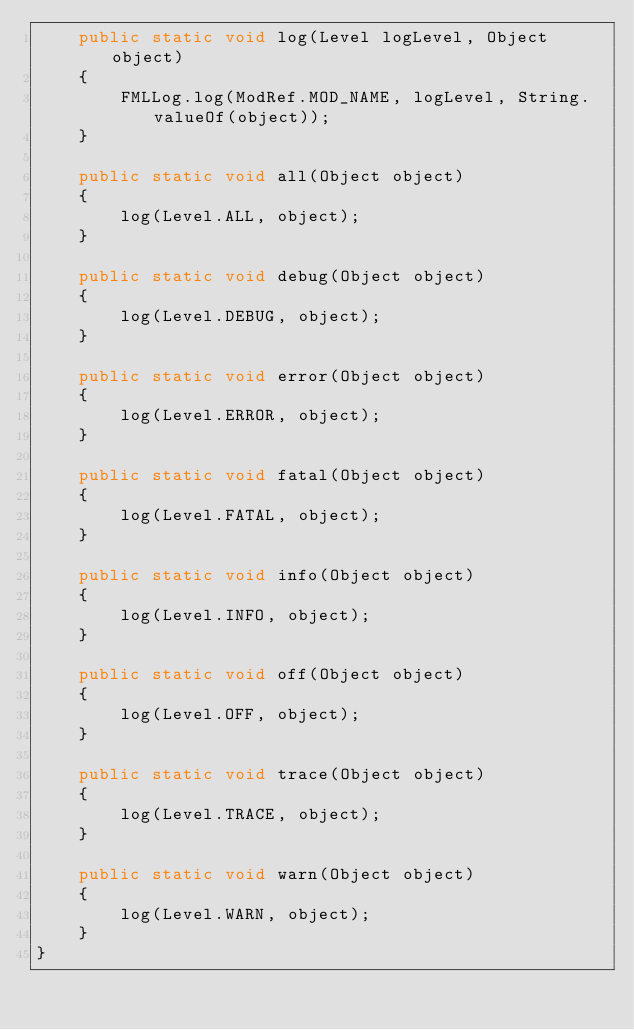Convert code to text. <code><loc_0><loc_0><loc_500><loc_500><_Java_>    public static void log(Level logLevel, Object object)
    {
        FMLLog.log(ModRef.MOD_NAME, logLevel, String.valueOf(object));
    }

    public static void all(Object object)
    {
        log(Level.ALL, object);
    }

    public static void debug(Object object)
    {
        log(Level.DEBUG, object);
    }

    public static void error(Object object)
    {
        log(Level.ERROR, object);
    }

    public static void fatal(Object object)
    {
        log(Level.FATAL, object);
    }

    public static void info(Object object)
    {
        log(Level.INFO, object);
    }

    public static void off(Object object)
    {
        log(Level.OFF, object);
    }

    public static void trace(Object object)
    {
        log(Level.TRACE, object);
    }

    public static void warn(Object object)
    {
        log(Level.WARN, object);
    }
}
</code> 